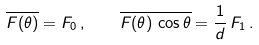Convert formula to latex. <formula><loc_0><loc_0><loc_500><loc_500>\overline { F ( \theta ) } = F _ { 0 } \, , \quad \overline { F ( \theta ) \, \cos \theta } = \frac { 1 } { d } \, F _ { 1 } \, .</formula> 